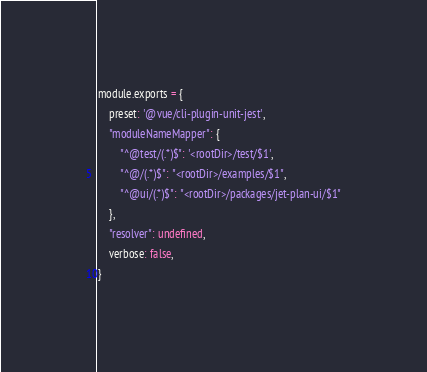Convert code to text. <code><loc_0><loc_0><loc_500><loc_500><_JavaScript_>module.exports = {
    preset: '@vue/cli-plugin-unit-jest',
    "moduleNameMapper": {
        "^@test/(.*)$": '<rootDir>/test/$1',
        "^@/(.*)$": "<rootDir>/examples/$1",
        "^@ui/(.*)$": "<rootDir>/packages/jet-plan-ui/$1"
    },
    "resolver": undefined,
    verbose: false,
}
</code> 